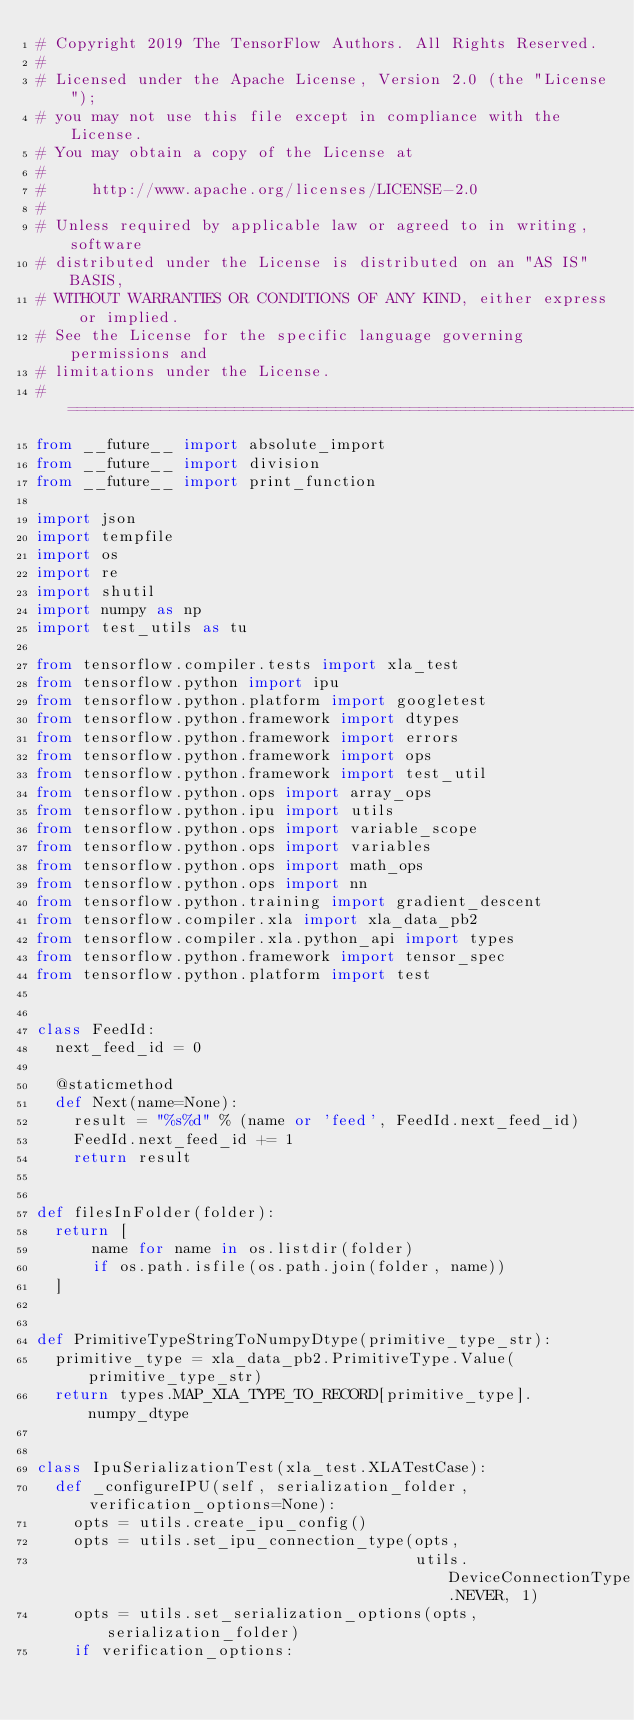Convert code to text. <code><loc_0><loc_0><loc_500><loc_500><_Python_># Copyright 2019 The TensorFlow Authors. All Rights Reserved.
#
# Licensed under the Apache License, Version 2.0 (the "License");
# you may not use this file except in compliance with the License.
# You may obtain a copy of the License at
#
#     http://www.apache.org/licenses/LICENSE-2.0
#
# Unless required by applicable law or agreed to in writing, software
# distributed under the License is distributed on an "AS IS" BASIS,
# WITHOUT WARRANTIES OR CONDITIONS OF ANY KIND, either express or implied.
# See the License for the specific language governing permissions and
# limitations under the License.
# =============================================================================
from __future__ import absolute_import
from __future__ import division
from __future__ import print_function

import json
import tempfile
import os
import re
import shutil
import numpy as np
import test_utils as tu

from tensorflow.compiler.tests import xla_test
from tensorflow.python import ipu
from tensorflow.python.platform import googletest
from tensorflow.python.framework import dtypes
from tensorflow.python.framework import errors
from tensorflow.python.framework import ops
from tensorflow.python.framework import test_util
from tensorflow.python.ops import array_ops
from tensorflow.python.ipu import utils
from tensorflow.python.ops import variable_scope
from tensorflow.python.ops import variables
from tensorflow.python.ops import math_ops
from tensorflow.python.ops import nn
from tensorflow.python.training import gradient_descent
from tensorflow.compiler.xla import xla_data_pb2
from tensorflow.compiler.xla.python_api import types
from tensorflow.python.framework import tensor_spec
from tensorflow.python.platform import test


class FeedId:
  next_feed_id = 0

  @staticmethod
  def Next(name=None):
    result = "%s%d" % (name or 'feed', FeedId.next_feed_id)
    FeedId.next_feed_id += 1
    return result


def filesInFolder(folder):
  return [
      name for name in os.listdir(folder)
      if os.path.isfile(os.path.join(folder, name))
  ]


def PrimitiveTypeStringToNumpyDtype(primitive_type_str):
  primitive_type = xla_data_pb2.PrimitiveType.Value(primitive_type_str)
  return types.MAP_XLA_TYPE_TO_RECORD[primitive_type].numpy_dtype


class IpuSerializationTest(xla_test.XLATestCase):
  def _configureIPU(self, serialization_folder, verification_options=None):
    opts = utils.create_ipu_config()
    opts = utils.set_ipu_connection_type(opts,
                                         utils.DeviceConnectionType.NEVER, 1)
    opts = utils.set_serialization_options(opts, serialization_folder)
    if verification_options:</code> 